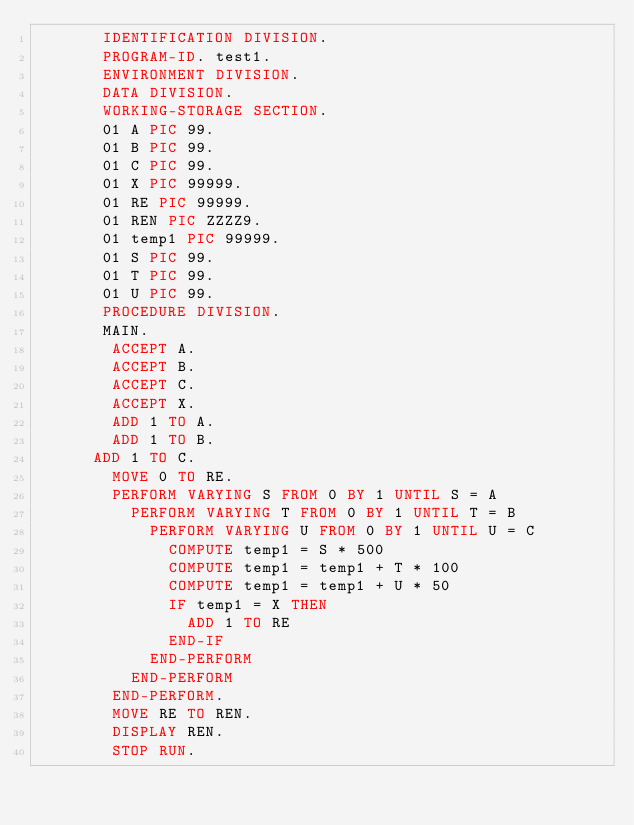<code> <loc_0><loc_0><loc_500><loc_500><_COBOL_>       IDENTIFICATION DIVISION.
       PROGRAM-ID. test1.
       ENVIRONMENT DIVISION.
       DATA DIVISION.
       WORKING-STORAGE SECTION.
       01 A PIC 99.
       01 B PIC 99.
       01 C PIC 99.
       01 X PIC 99999.
       01 RE PIC 99999.
       01 REN PIC ZZZZ9.
       01 temp1 PIC 99999.
       01 S PIC 99.
       01 T PIC 99.
       01 U PIC 99.
       PROCEDURE DIVISION.
       MAIN.
      	ACCEPT A.
      	ACCEPT B.
      	ACCEPT C.
      	ACCEPT X.
      	ADD 1 TO A.
      	ADD 1 TO B.
     	ADD 1 TO C.
      	MOVE 0 TO RE.
      	PERFORM VARYING S FROM 0 BY 1 UNTIL S = A
      		PERFORM VARYING T FROM 0 BY 1 UNTIL T = B
      			PERFORM VARYING U FROM 0 BY 1 UNTIL U = C
      				COMPUTE temp1 = S * 500
      				COMPUTE temp1 = temp1 + T * 100
      				COMPUTE temp1 = temp1 + U * 50
      				IF temp1 = X THEN
      					ADD 1 TO RE
      				END-IF
      			END-PERFORM
      		END-PERFORM
      	END-PERFORM.
      	MOVE RE TO REN.
      	DISPLAY REN.
        STOP RUN.



</code> 